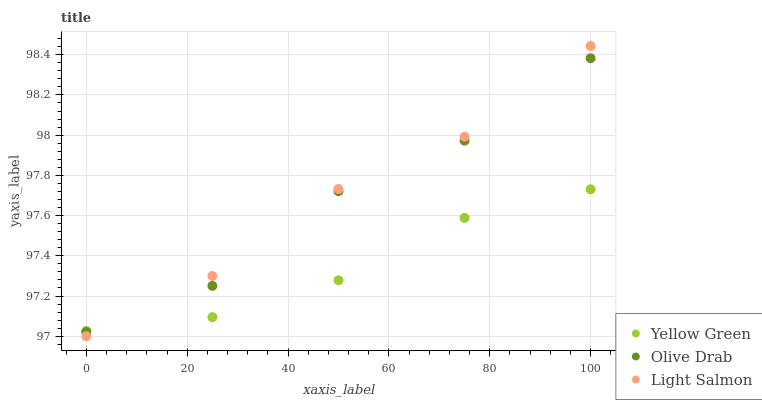Does Yellow Green have the minimum area under the curve?
Answer yes or no. Yes. Does Light Salmon have the maximum area under the curve?
Answer yes or no. Yes. Does Olive Drab have the minimum area under the curve?
Answer yes or no. No. Does Olive Drab have the maximum area under the curve?
Answer yes or no. No. Is Yellow Green the smoothest?
Answer yes or no. Yes. Is Olive Drab the roughest?
Answer yes or no. Yes. Is Olive Drab the smoothest?
Answer yes or no. No. Is Yellow Green the roughest?
Answer yes or no. No. Does Light Salmon have the lowest value?
Answer yes or no. Yes. Does Olive Drab have the lowest value?
Answer yes or no. No. Does Light Salmon have the highest value?
Answer yes or no. Yes. Does Olive Drab have the highest value?
Answer yes or no. No. Does Light Salmon intersect Yellow Green?
Answer yes or no. Yes. Is Light Salmon less than Yellow Green?
Answer yes or no. No. Is Light Salmon greater than Yellow Green?
Answer yes or no. No. 